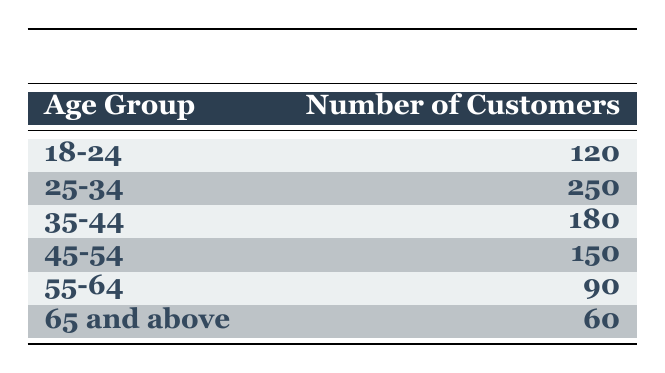What is the total number of customers in the age group 25-34? The table shows that the number of customers in the age group 25-34 is 250.
Answer: 250 Which age group has the highest number of customers? By examining the "Number of Customers" column, the highest value is 250 in the age group 25-34.
Answer: 25-34 How many customers are aged 45 and older? To find this, add the number of customers in the age groups 45-54, 55-64, and 65 and above: 150 + 90 + 60 = 300.
Answer: 300 Is the number of customers in the age group 18-24 greater than that in the 55-64 age group? The number of customers aged 18-24 is 120, while those aged 55-64 is 90. Since 120 is greater than 90, the statement is true.
Answer: Yes What is the average number of customers across all age groups? To find the average, sum all the customers: 120 + 250 + 180 + 150 + 90 + 60 = 850. There are 6 age groups, so divide 850 by 6, which gives approximately 141.67.
Answer: 141.67 Which age group has the least number of customers? Upon reviewing the table, the least number of customers is in the age group 65 and above, with only 60 customers.
Answer: 65 and above What is the difference in the number of customers between the age groups 35-44 and 55-64? The number of customers in the age group 35-44 is 180, and in 55-64 is 90. Subtracting gives 180 - 90 = 90.
Answer: 90 Do more customers purchase art in the age group 45-54 than in the age group 65 and above? The number of customers in 45-54 is 150, while in 65 and above it is 60. Since 150 is greater than 60, the statement is true.
Answer: Yes 